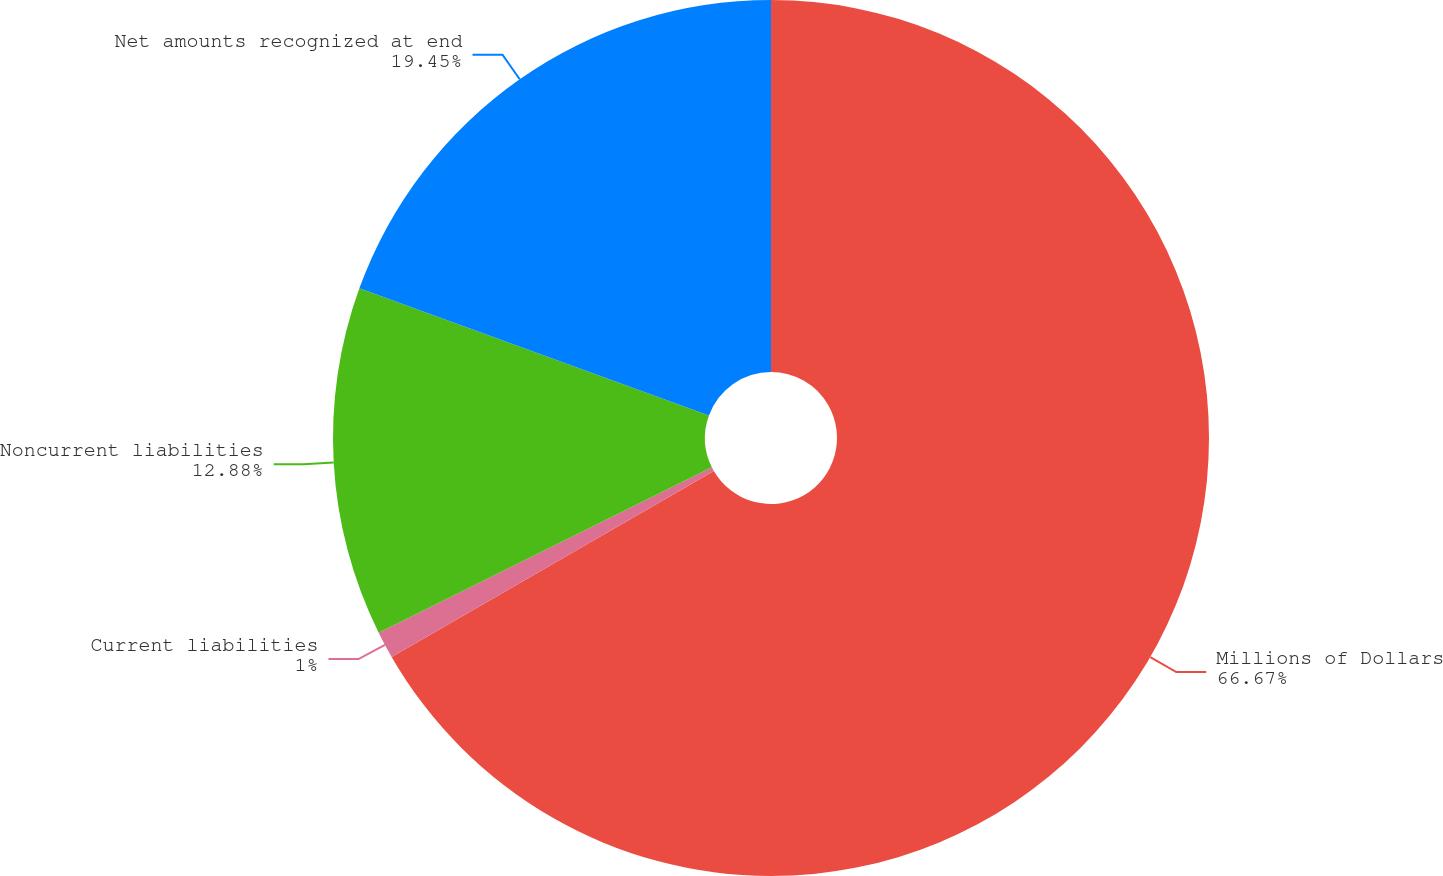<chart> <loc_0><loc_0><loc_500><loc_500><pie_chart><fcel>Millions of Dollars<fcel>Current liabilities<fcel>Noncurrent liabilities<fcel>Net amounts recognized at end<nl><fcel>66.67%<fcel>1.0%<fcel>12.88%<fcel>19.45%<nl></chart> 